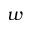<formula> <loc_0><loc_0><loc_500><loc_500>w</formula> 